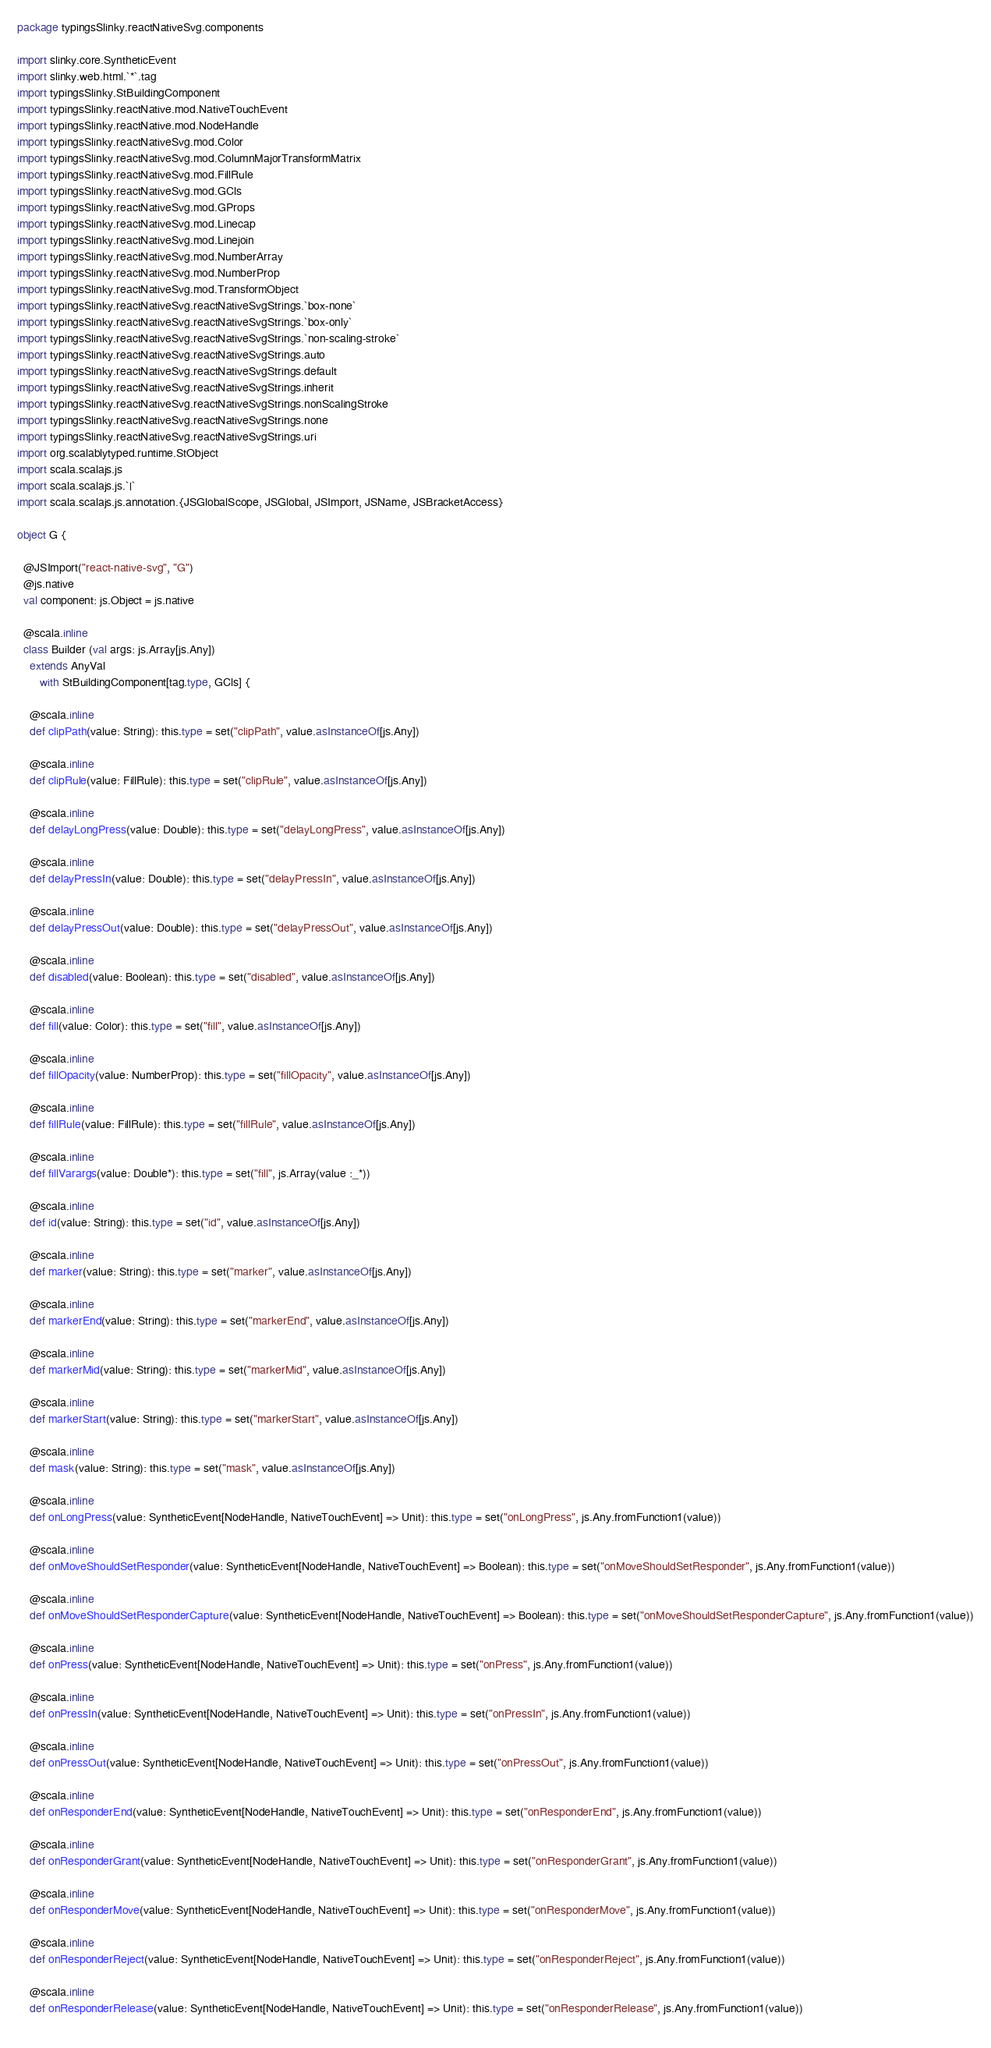Convert code to text. <code><loc_0><loc_0><loc_500><loc_500><_Scala_>package typingsSlinky.reactNativeSvg.components

import slinky.core.SyntheticEvent
import slinky.web.html.`*`.tag
import typingsSlinky.StBuildingComponent
import typingsSlinky.reactNative.mod.NativeTouchEvent
import typingsSlinky.reactNative.mod.NodeHandle
import typingsSlinky.reactNativeSvg.mod.Color
import typingsSlinky.reactNativeSvg.mod.ColumnMajorTransformMatrix
import typingsSlinky.reactNativeSvg.mod.FillRule
import typingsSlinky.reactNativeSvg.mod.GCls
import typingsSlinky.reactNativeSvg.mod.GProps
import typingsSlinky.reactNativeSvg.mod.Linecap
import typingsSlinky.reactNativeSvg.mod.Linejoin
import typingsSlinky.reactNativeSvg.mod.NumberArray
import typingsSlinky.reactNativeSvg.mod.NumberProp
import typingsSlinky.reactNativeSvg.mod.TransformObject
import typingsSlinky.reactNativeSvg.reactNativeSvgStrings.`box-none`
import typingsSlinky.reactNativeSvg.reactNativeSvgStrings.`box-only`
import typingsSlinky.reactNativeSvg.reactNativeSvgStrings.`non-scaling-stroke`
import typingsSlinky.reactNativeSvg.reactNativeSvgStrings.auto
import typingsSlinky.reactNativeSvg.reactNativeSvgStrings.default
import typingsSlinky.reactNativeSvg.reactNativeSvgStrings.inherit
import typingsSlinky.reactNativeSvg.reactNativeSvgStrings.nonScalingStroke
import typingsSlinky.reactNativeSvg.reactNativeSvgStrings.none
import typingsSlinky.reactNativeSvg.reactNativeSvgStrings.uri
import org.scalablytyped.runtime.StObject
import scala.scalajs.js
import scala.scalajs.js.`|`
import scala.scalajs.js.annotation.{JSGlobalScope, JSGlobal, JSImport, JSName, JSBracketAccess}

object G {
  
  @JSImport("react-native-svg", "G")
  @js.native
  val component: js.Object = js.native
  
  @scala.inline
  class Builder (val args: js.Array[js.Any])
    extends AnyVal
       with StBuildingComponent[tag.type, GCls] {
    
    @scala.inline
    def clipPath(value: String): this.type = set("clipPath", value.asInstanceOf[js.Any])
    
    @scala.inline
    def clipRule(value: FillRule): this.type = set("clipRule", value.asInstanceOf[js.Any])
    
    @scala.inline
    def delayLongPress(value: Double): this.type = set("delayLongPress", value.asInstanceOf[js.Any])
    
    @scala.inline
    def delayPressIn(value: Double): this.type = set("delayPressIn", value.asInstanceOf[js.Any])
    
    @scala.inline
    def delayPressOut(value: Double): this.type = set("delayPressOut", value.asInstanceOf[js.Any])
    
    @scala.inline
    def disabled(value: Boolean): this.type = set("disabled", value.asInstanceOf[js.Any])
    
    @scala.inline
    def fill(value: Color): this.type = set("fill", value.asInstanceOf[js.Any])
    
    @scala.inline
    def fillOpacity(value: NumberProp): this.type = set("fillOpacity", value.asInstanceOf[js.Any])
    
    @scala.inline
    def fillRule(value: FillRule): this.type = set("fillRule", value.asInstanceOf[js.Any])
    
    @scala.inline
    def fillVarargs(value: Double*): this.type = set("fill", js.Array(value :_*))
    
    @scala.inline
    def id(value: String): this.type = set("id", value.asInstanceOf[js.Any])
    
    @scala.inline
    def marker(value: String): this.type = set("marker", value.asInstanceOf[js.Any])
    
    @scala.inline
    def markerEnd(value: String): this.type = set("markerEnd", value.asInstanceOf[js.Any])
    
    @scala.inline
    def markerMid(value: String): this.type = set("markerMid", value.asInstanceOf[js.Any])
    
    @scala.inline
    def markerStart(value: String): this.type = set("markerStart", value.asInstanceOf[js.Any])
    
    @scala.inline
    def mask(value: String): this.type = set("mask", value.asInstanceOf[js.Any])
    
    @scala.inline
    def onLongPress(value: SyntheticEvent[NodeHandle, NativeTouchEvent] => Unit): this.type = set("onLongPress", js.Any.fromFunction1(value))
    
    @scala.inline
    def onMoveShouldSetResponder(value: SyntheticEvent[NodeHandle, NativeTouchEvent] => Boolean): this.type = set("onMoveShouldSetResponder", js.Any.fromFunction1(value))
    
    @scala.inline
    def onMoveShouldSetResponderCapture(value: SyntheticEvent[NodeHandle, NativeTouchEvent] => Boolean): this.type = set("onMoveShouldSetResponderCapture", js.Any.fromFunction1(value))
    
    @scala.inline
    def onPress(value: SyntheticEvent[NodeHandle, NativeTouchEvent] => Unit): this.type = set("onPress", js.Any.fromFunction1(value))
    
    @scala.inline
    def onPressIn(value: SyntheticEvent[NodeHandle, NativeTouchEvent] => Unit): this.type = set("onPressIn", js.Any.fromFunction1(value))
    
    @scala.inline
    def onPressOut(value: SyntheticEvent[NodeHandle, NativeTouchEvent] => Unit): this.type = set("onPressOut", js.Any.fromFunction1(value))
    
    @scala.inline
    def onResponderEnd(value: SyntheticEvent[NodeHandle, NativeTouchEvent] => Unit): this.type = set("onResponderEnd", js.Any.fromFunction1(value))
    
    @scala.inline
    def onResponderGrant(value: SyntheticEvent[NodeHandle, NativeTouchEvent] => Unit): this.type = set("onResponderGrant", js.Any.fromFunction1(value))
    
    @scala.inline
    def onResponderMove(value: SyntheticEvent[NodeHandle, NativeTouchEvent] => Unit): this.type = set("onResponderMove", js.Any.fromFunction1(value))
    
    @scala.inline
    def onResponderReject(value: SyntheticEvent[NodeHandle, NativeTouchEvent] => Unit): this.type = set("onResponderReject", js.Any.fromFunction1(value))
    
    @scala.inline
    def onResponderRelease(value: SyntheticEvent[NodeHandle, NativeTouchEvent] => Unit): this.type = set("onResponderRelease", js.Any.fromFunction1(value))
    </code> 